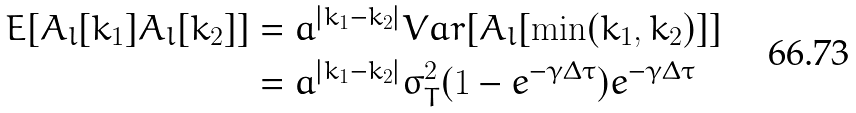<formula> <loc_0><loc_0><loc_500><loc_500>E [ A _ { l } [ k _ { 1 } ] A _ { l } [ k _ { 2 } ] ] & = a ^ { | k _ { 1 } - k _ { 2 } | } V a r [ A _ { l } [ \min ( k _ { 1 } , k _ { 2 } ) ] ] \\ & = a ^ { | k _ { 1 } - k _ { 2 } | } \sigma _ { T } ^ { 2 } ( 1 - e ^ { - \gamma \Delta \tau } ) e ^ { - \gamma \Delta \tau }</formula> 